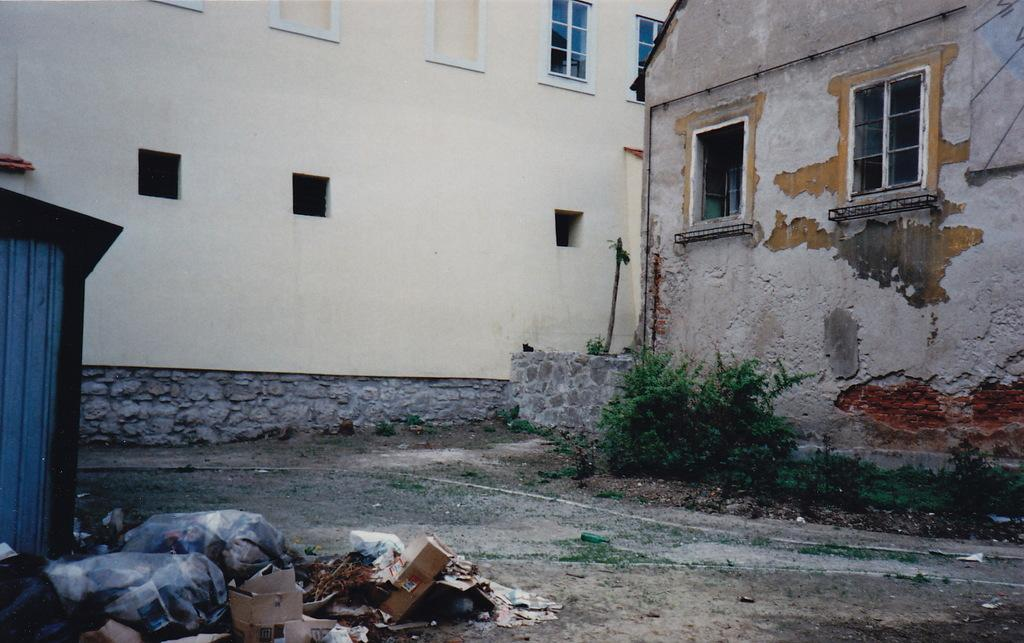What type of structures can be seen in the image? There are houses in the image. What feature do the houses have? The houses have windows. What objects are related to waste management in the image? Garbage covers are present in the image. What type of packaging material is visible in the image? Cardboard boxes are visible in the image. What type of vegetation is present in the image? There are plants in the image. Can you see any blood stains on the houses in the image? There are no blood stains visible in the image. What type of lake can be seen in the image? There is no lake present in the image. 